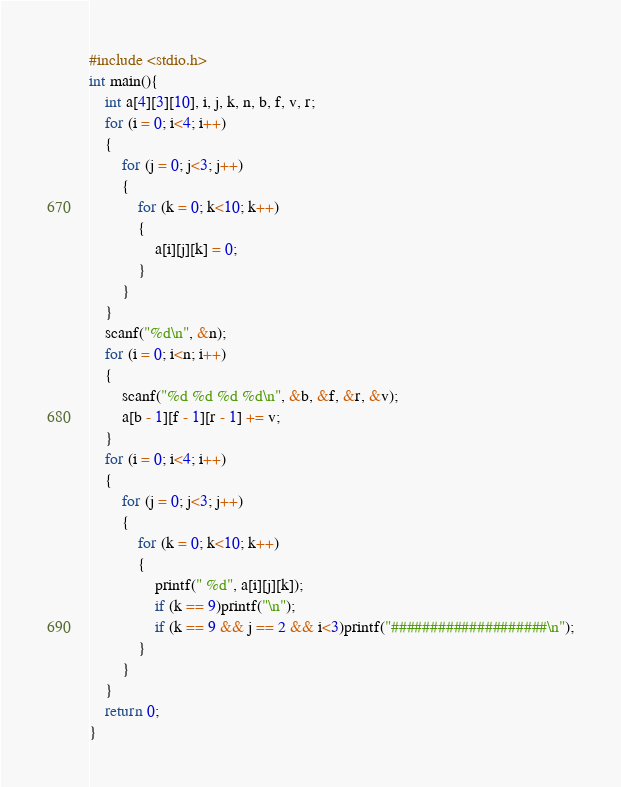<code> <loc_0><loc_0><loc_500><loc_500><_C_>#include <stdio.h>
int main(){
	int a[4][3][10], i, j, k, n, b, f, v, r;
	for (i = 0; i<4; i++)
	{
		for (j = 0; j<3; j++)
		{
			for (k = 0; k<10; k++)
			{
				a[i][j][k] = 0;
			}
		}
	}
	scanf("%d\n", &n);
	for (i = 0; i<n; i++)
	{
		scanf("%d %d %d %d\n", &b, &f, &r, &v);
		a[b - 1][f - 1][r - 1] += v;
	}
	for (i = 0; i<4; i++)
	{
		for (j = 0; j<3; j++)
		{
			for (k = 0; k<10; k++)
			{
				printf(" %d", a[i][j][k]);
				if (k == 9)printf("\n");
				if (k == 9 && j == 2 && i<3)printf("####################\n");
			}
		}
	}
	return 0;
}
</code> 